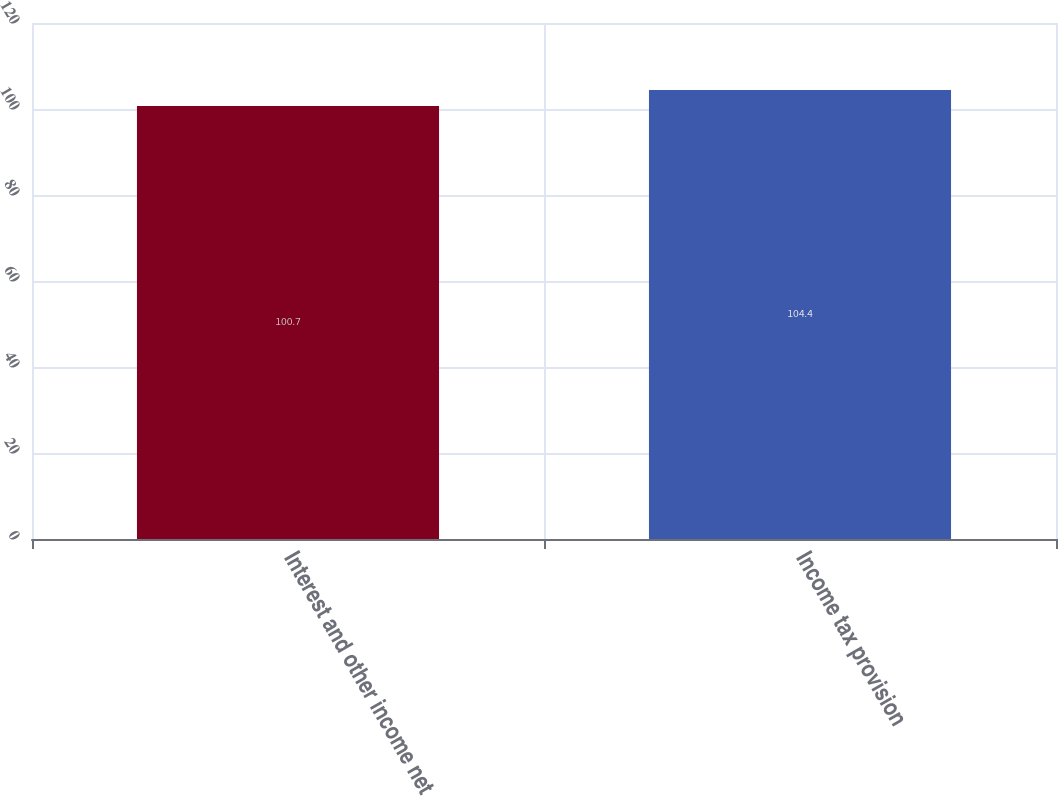<chart> <loc_0><loc_0><loc_500><loc_500><bar_chart><fcel>Interest and other income net<fcel>Income tax provision<nl><fcel>100.7<fcel>104.4<nl></chart> 